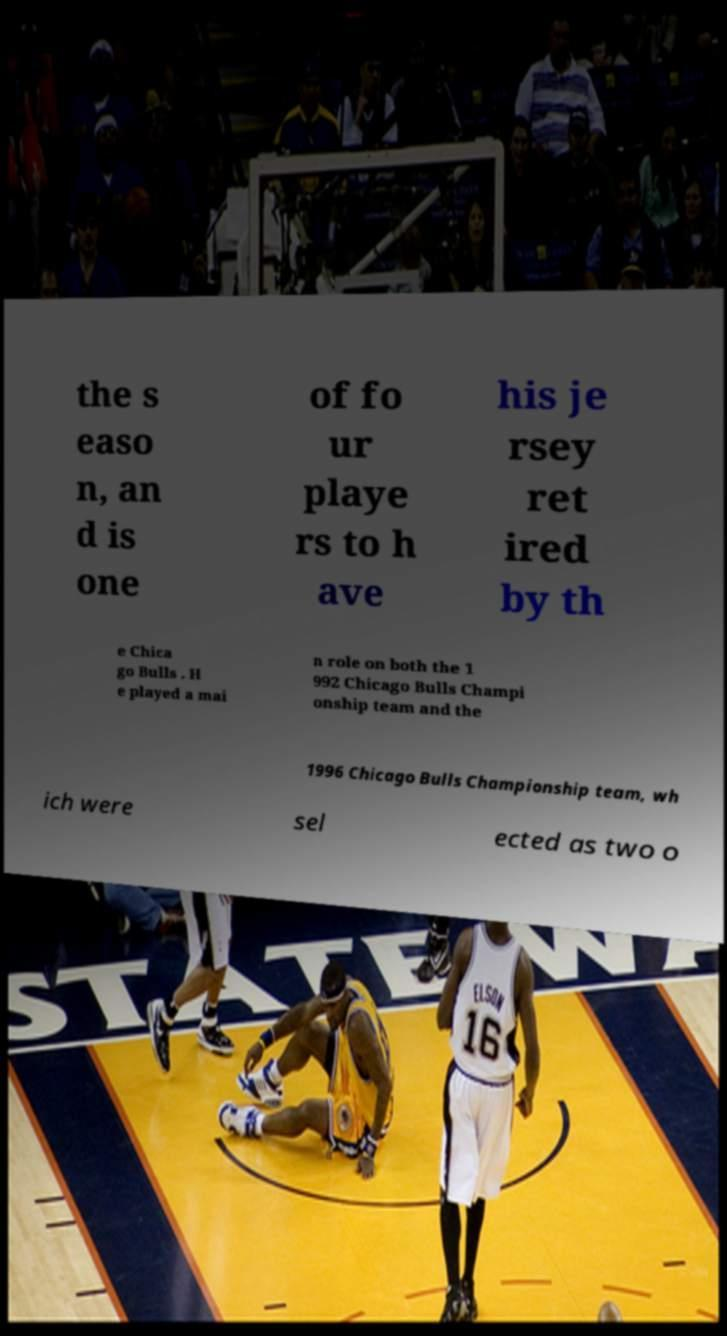Can you read and provide the text displayed in the image?This photo seems to have some interesting text. Can you extract and type it out for me? the s easo n, an d is one of fo ur playe rs to h ave his je rsey ret ired by th e Chica go Bulls . H e played a mai n role on both the 1 992 Chicago Bulls Champi onship team and the 1996 Chicago Bulls Championship team, wh ich were sel ected as two o 